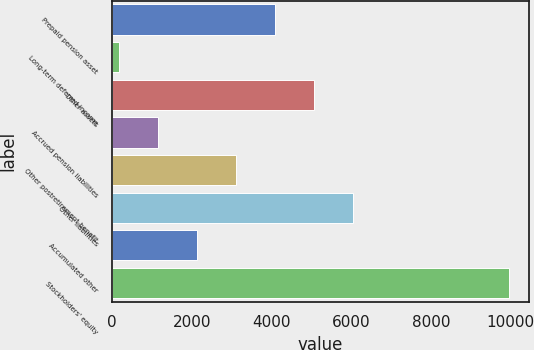Convert chart to OTSL. <chart><loc_0><loc_0><loc_500><loc_500><bar_chart><fcel>Prepaid pension asset<fcel>Long-term deferred income<fcel>Other assets<fcel>Accrued pension liabilities<fcel>Other postretirement benefit<fcel>Other liabilities<fcel>Accumulated other<fcel>Stockholders' equity<nl><fcel>4081.4<fcel>167<fcel>5060<fcel>1145.6<fcel>3102.8<fcel>6038.6<fcel>2124.2<fcel>9953<nl></chart> 